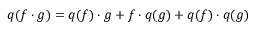Convert formula to latex. <formula><loc_0><loc_0><loc_500><loc_500>q ( f \cdot g ) = q ( f ) \cdot g + f \cdot q ( g ) + q ( f ) \cdot q ( g )</formula> 